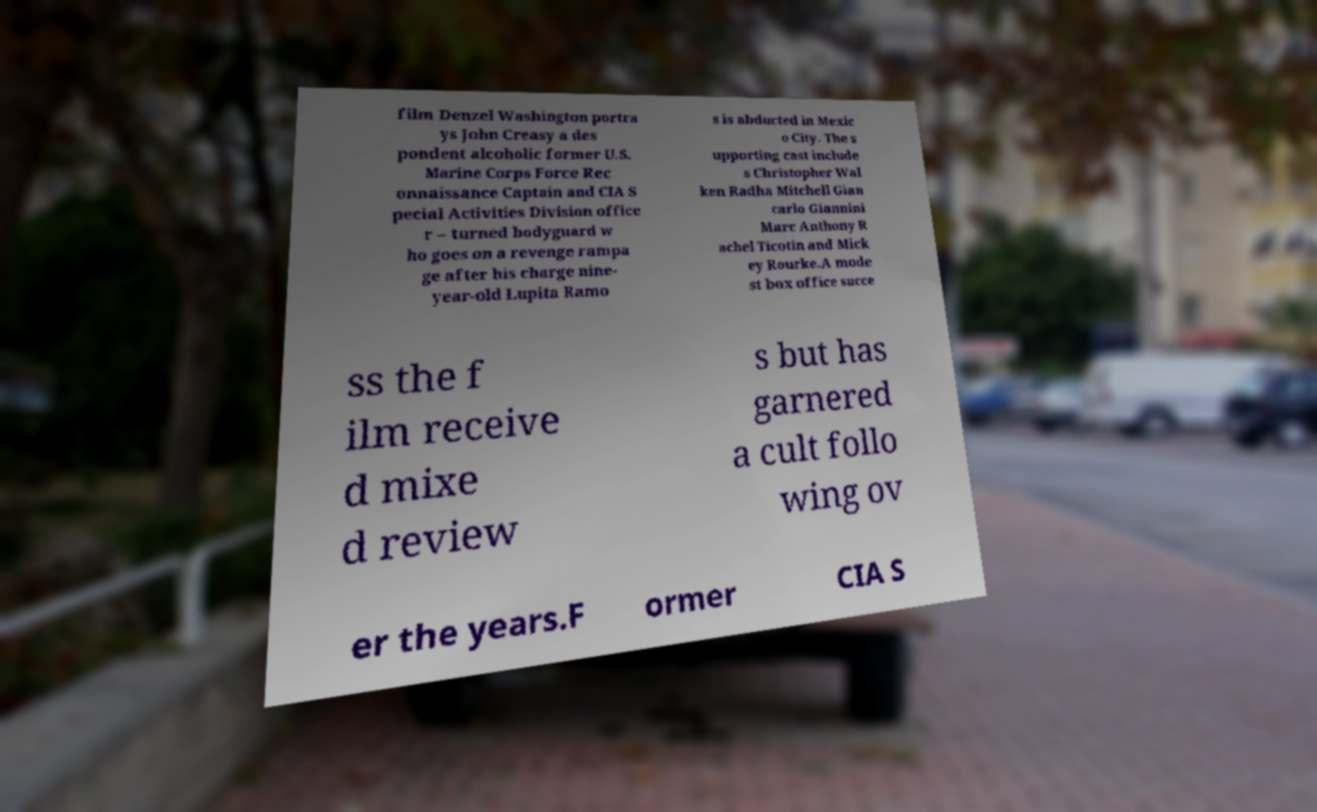For documentation purposes, I need the text within this image transcribed. Could you provide that? film Denzel Washington portra ys John Creasy a des pondent alcoholic former U.S. Marine Corps Force Rec onnaissance Captain and CIA S pecial Activities Division office r – turned bodyguard w ho goes on a revenge rampa ge after his charge nine- year-old Lupita Ramo s is abducted in Mexic o City. The s upporting cast include s Christopher Wal ken Radha Mitchell Gian carlo Giannini Marc Anthony R achel Ticotin and Mick ey Rourke.A mode st box office succe ss the f ilm receive d mixe d review s but has garnered a cult follo wing ov er the years.F ormer CIA S 